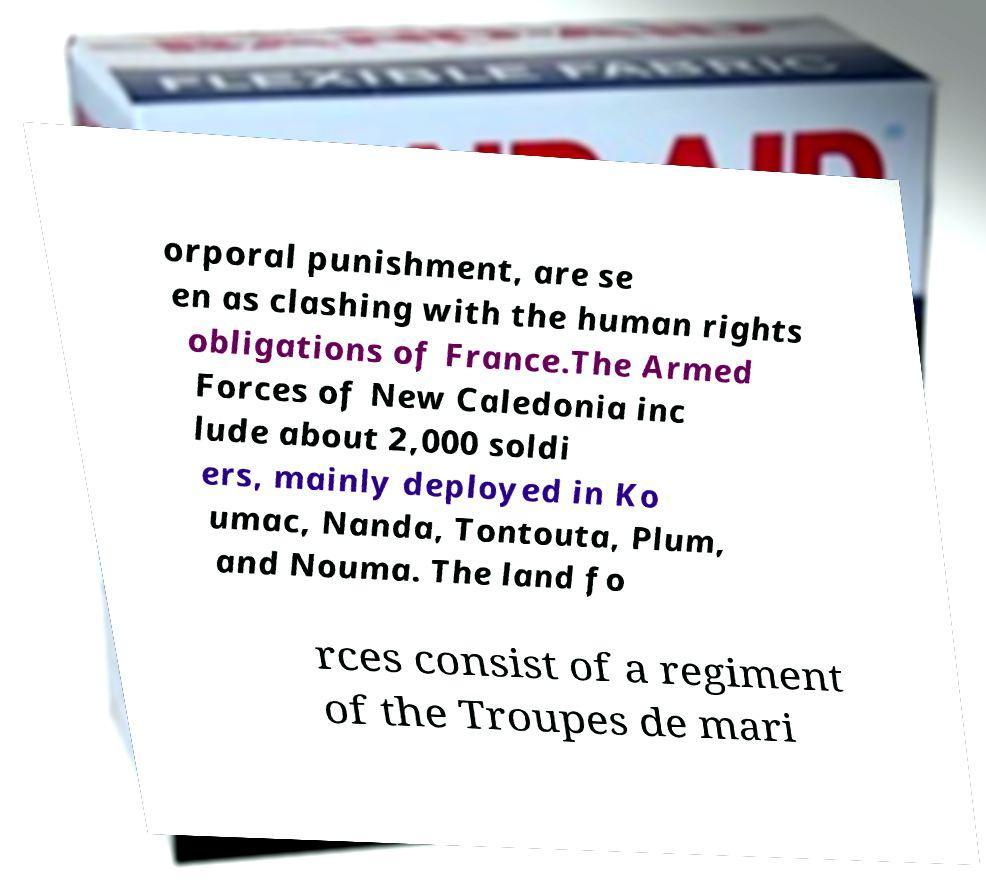Please read and relay the text visible in this image. What does it say? orporal punishment, are se en as clashing with the human rights obligations of France.The Armed Forces of New Caledonia inc lude about 2,000 soldi ers, mainly deployed in Ko umac, Nanda, Tontouta, Plum, and Nouma. The land fo rces consist of a regiment of the Troupes de mari 